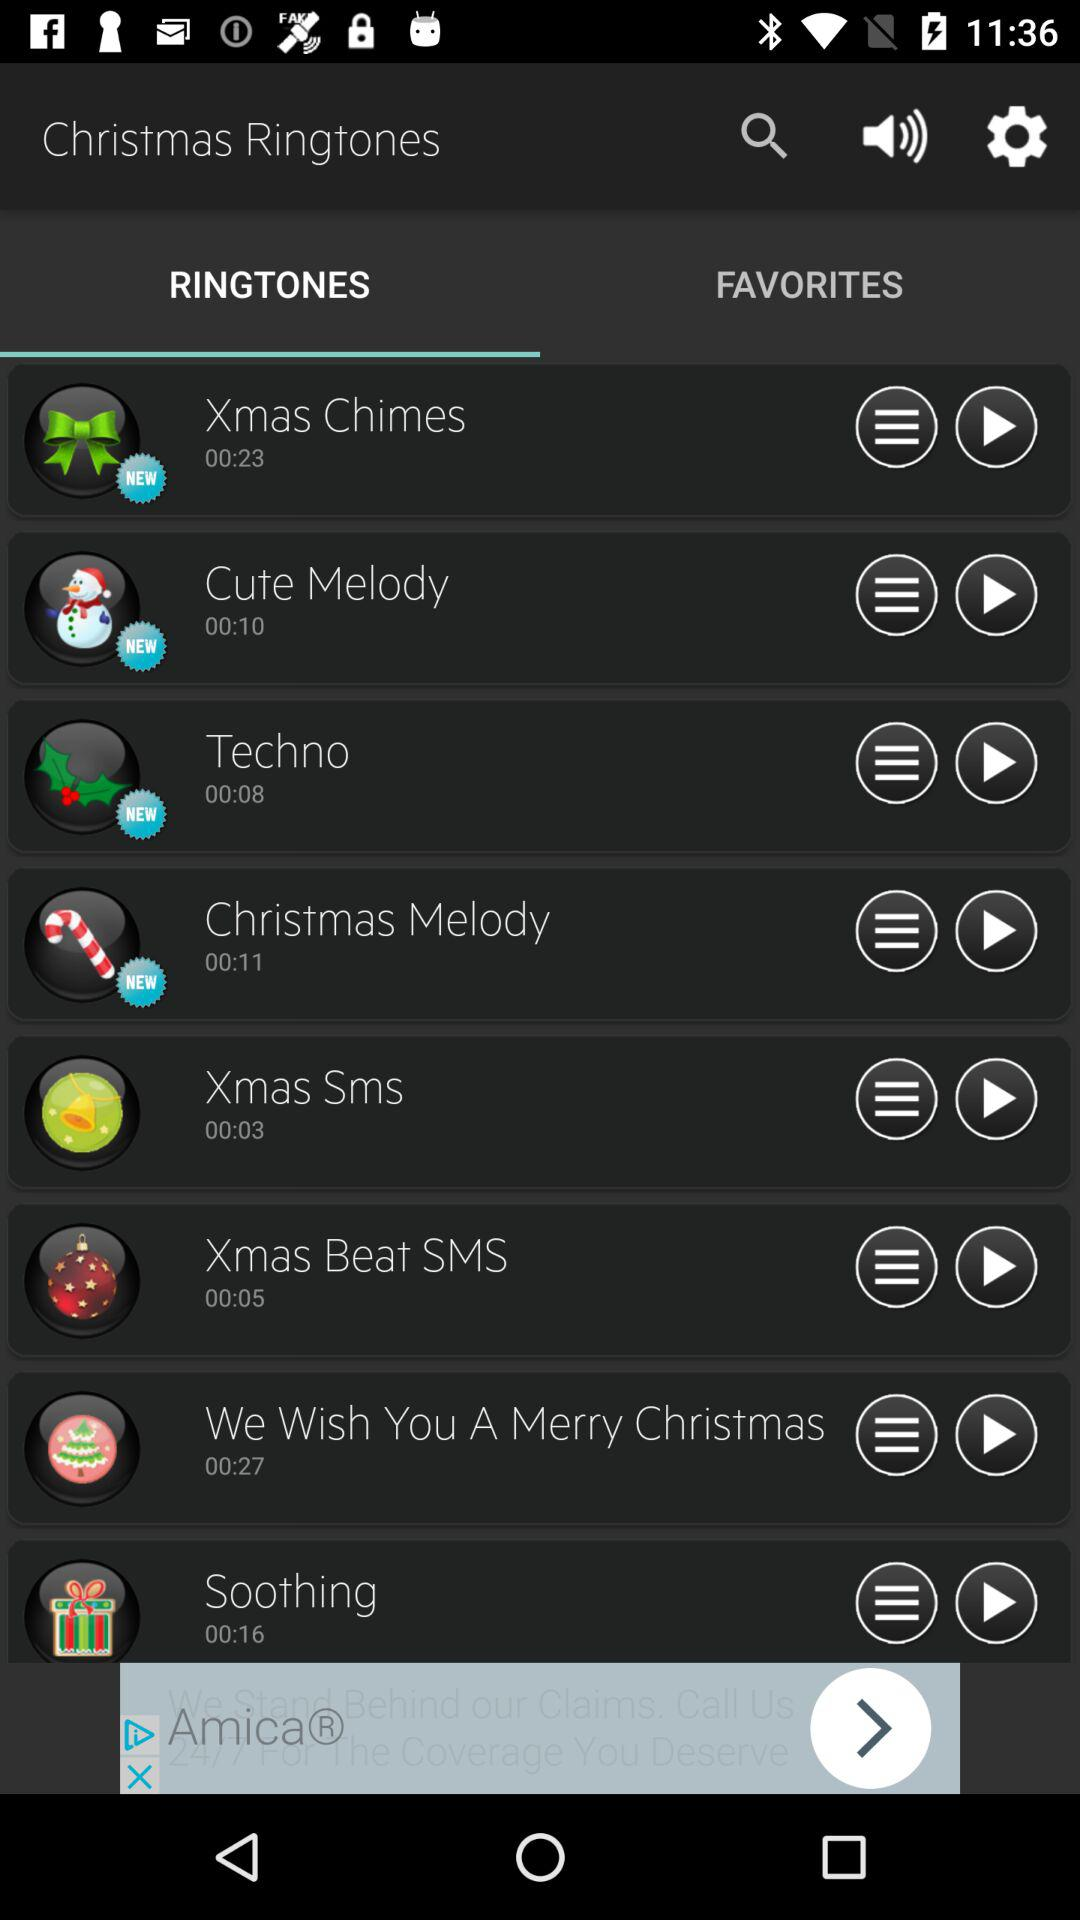What is the duration of the "Soothing" ringtone? The duration is 00:16. 